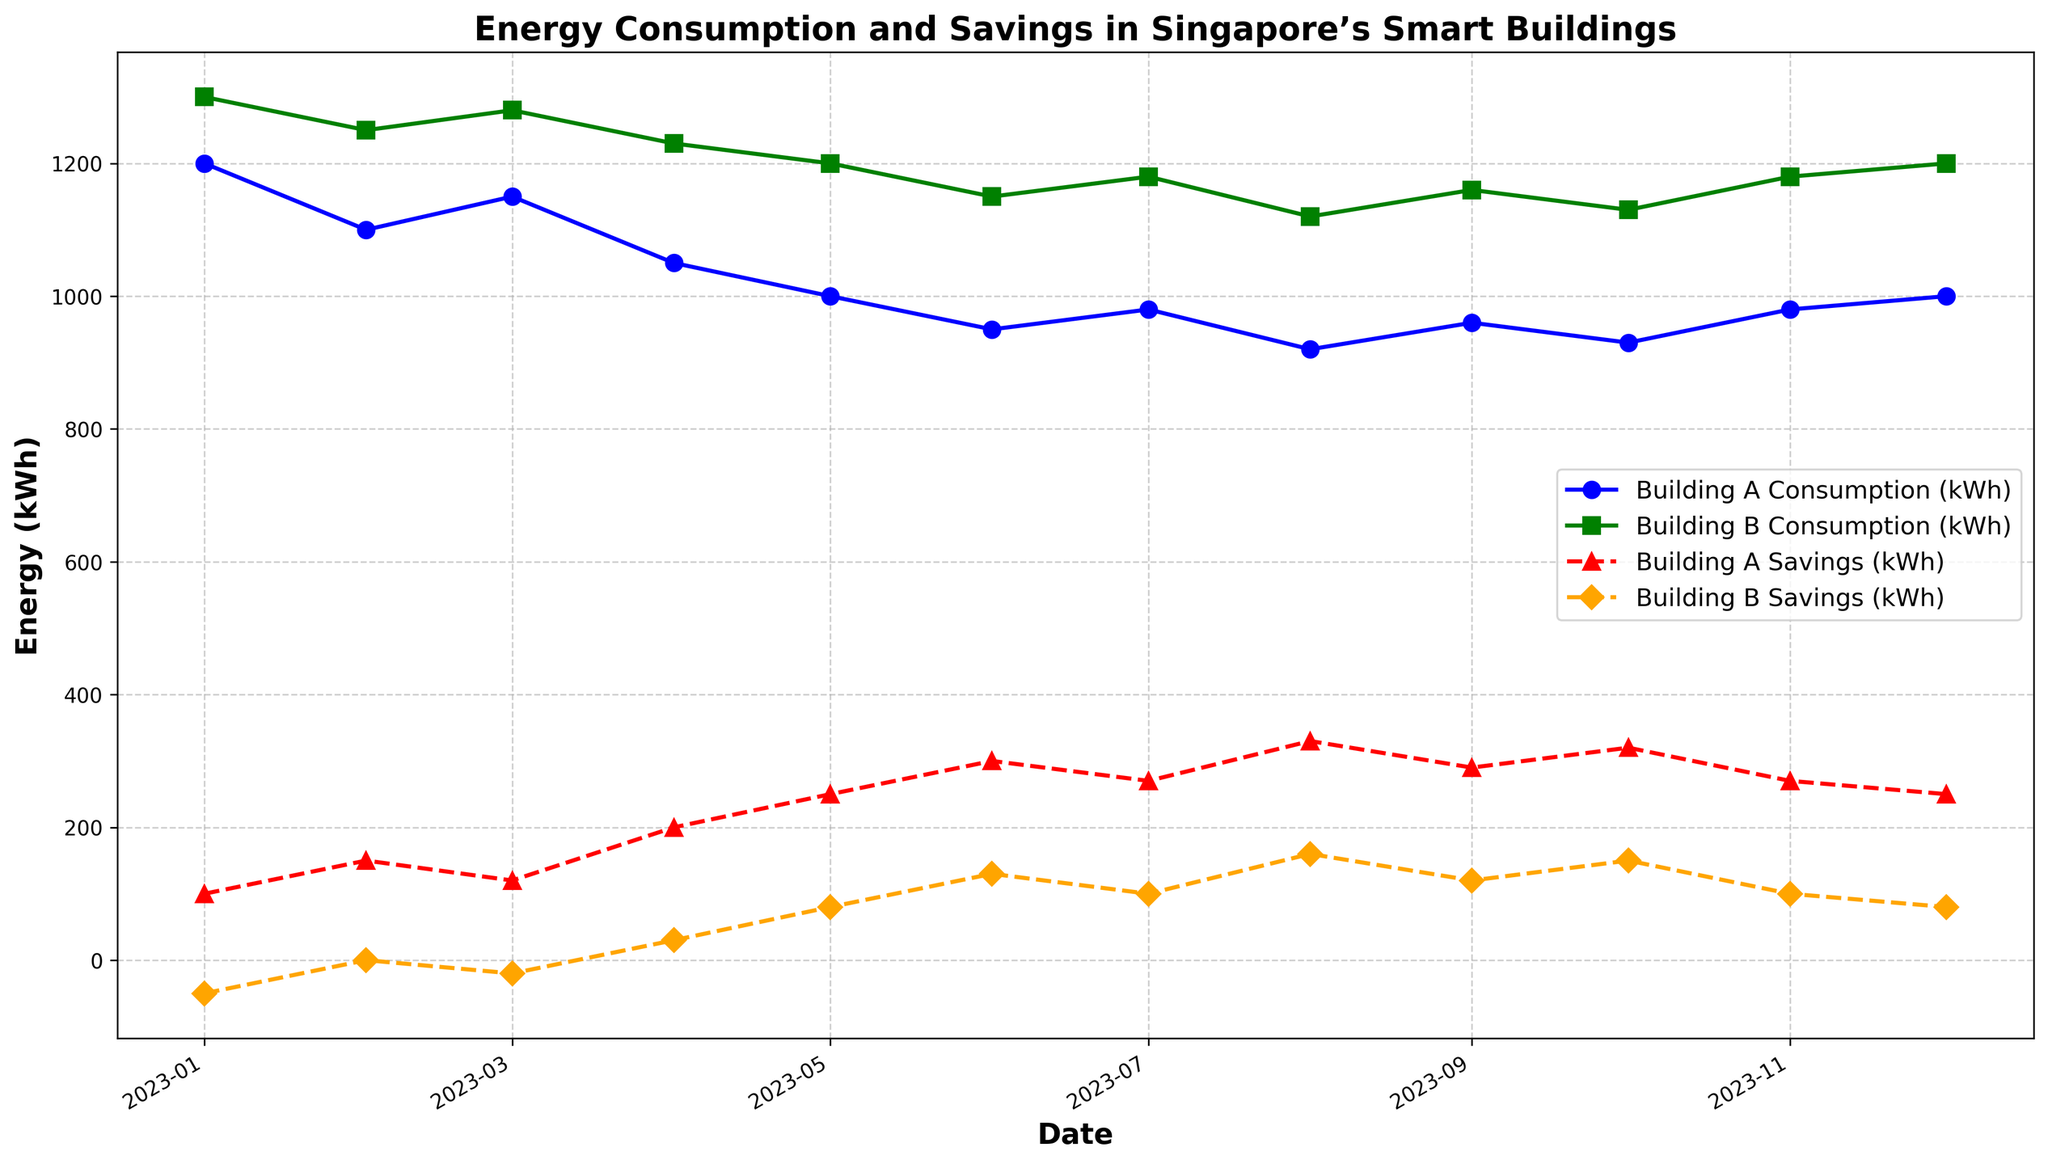Which building has lower energy consumption in January 2023? By observing the plot's blue and green lines, we can compare the January 2023 points. The Building A line (blue) is at 1200 kWh and the Building B line (green) is at 1300 kWh, indicating Building A consumes less.
Answer: Building A In which month did Building A achieve its highest savings? By looking at the red line representing Building A Savings, the highest point is found in August with a savings value of 330 kWh.
Answer: August 2023 How did Building B's energy consumption change from June to July 2023? By observing the green line from June to July, Building B's energy consumption increased from 1150 kWh to 1180 kWh.
Answer: It increased What is the sum of Building A's energy consumption in April and May 2023? The blue line shows that Building A's energy consumption is 1050 kWh in April and 1000 kWh in May. Summing these values gives 1050 + 1000 = 2050 kWh.
Answer: 2050 kWh Which month features the highest savings for Building B? By examining the orange line for Building B Savings, the highest point is in August with a savings value of 160 kWh.
Answer: August 2023 Compare the energy consumption of Buildings A and B in December 2023. Which building has higher consumption? By checking the blue and green lines in December, Building A has 1000 kWh and Building B has 1200 kWh, making Building B's consumption higher.
Answer: Building B What is the difference in savings between Building A and Building B in June 2023? In June, the red line (Building A Savings) shows 300 kWh and the orange line (Building B Savings) shows 130 kWh. The difference is 300 - 130 = 170 kWh.
Answer: 170 kWh Which building showed a decreasing trend in energy consumption from January to May 2023? By analyzing both blue and green lines, only Building A (blue) shows a clear decreasing trend from January's 1200 kWh to May's 1000 kWh.
Answer: Building A What is the total savings for Building B in the last quarter of 2023? From the orange line, Building B Savings are 120 kWh (Oct), 100 kWh (Nov), and 80 kWh (Dec). Total savings: 120 + 100 + 80 = 300 kWh.
Answer: 300 kWh Did Building A consistently have positive savings throughout 2023? The red line representing Building A Savings never dips below zero, indicating consistent positive savings throughout the year.
Answer: Yes 